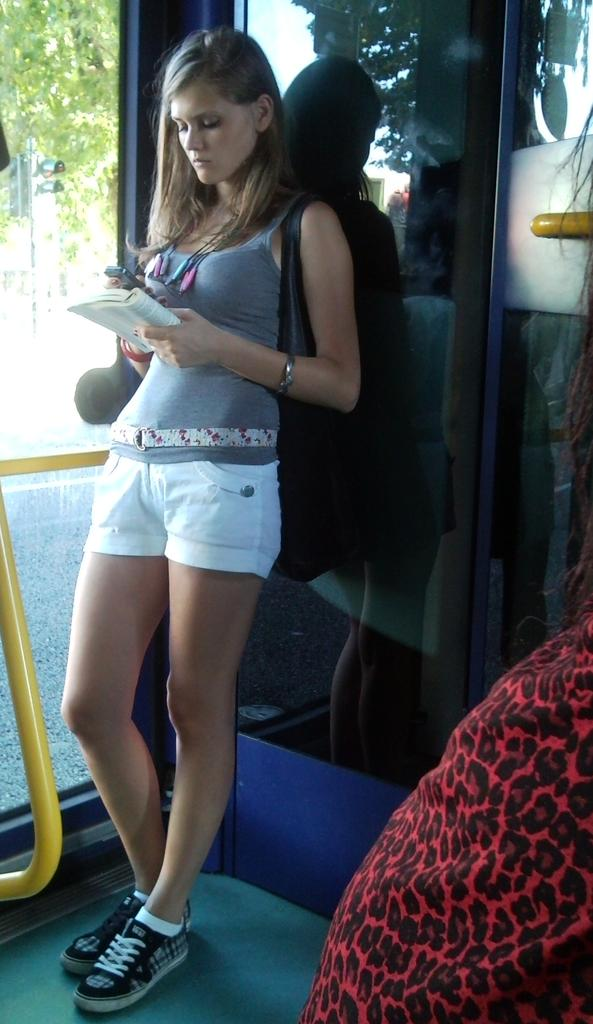Who is present in the image? There is a woman in the image. What is the woman doing in the image? The woman is standing and leaning on a glass door. What is the woman holding in the image? The woman is holding a book and a mobile. What can be seen in the background of the image? There are trees visible at the top left side of the image. What is the woman's opinion on steel in the image? There is no information about the woman's opinion on steel in the image. 